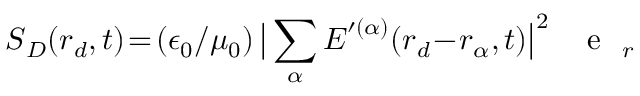Convert formula to latex. <formula><loc_0><loc_0><loc_500><loc_500>S _ { D } ( r _ { d } , t ) \, = \, ( \epsilon _ { 0 } / \mu _ { 0 } ) \, \left | \sum _ { \alpha } E ^ { \prime ( \alpha ) } ( r _ { d } \, - \, r _ { \alpha } , t ) \right | ^ { 2 } \, { e } _ { r }</formula> 